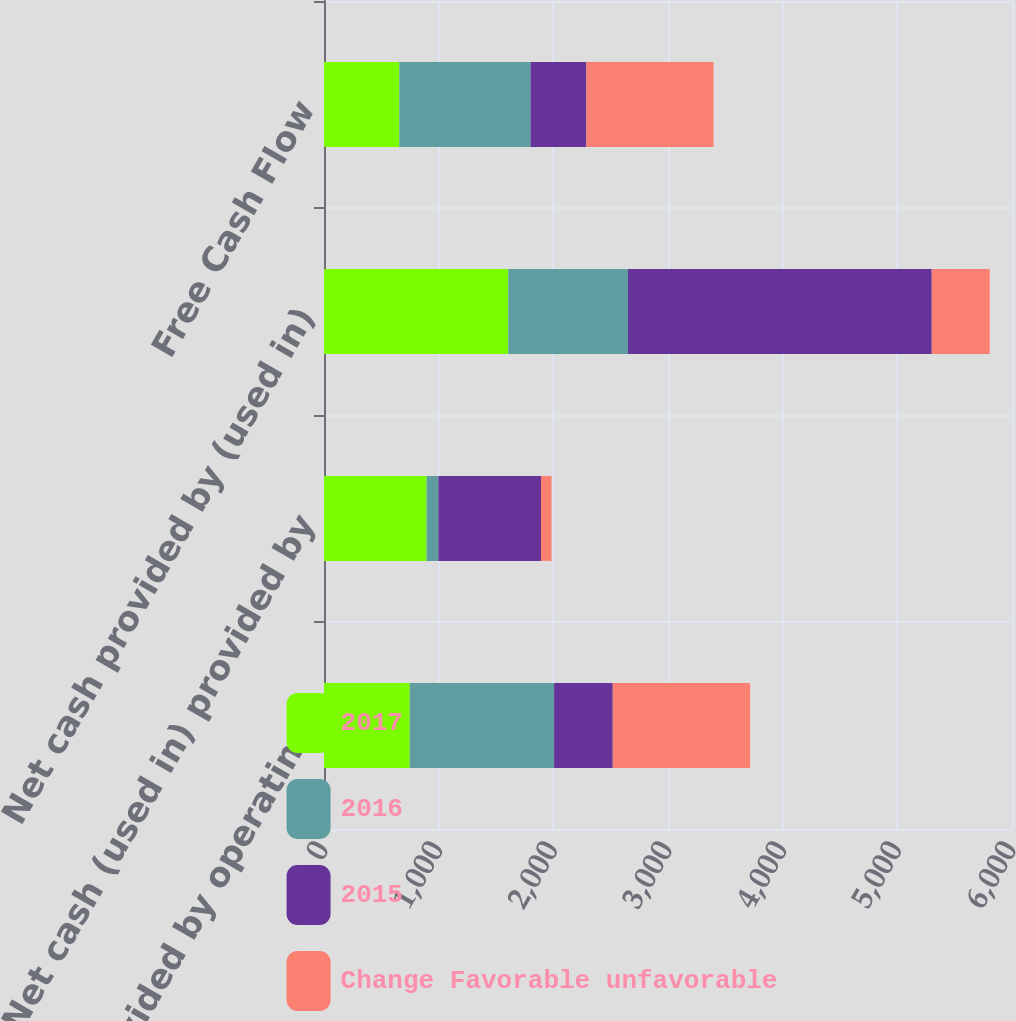Convert chart. <chart><loc_0><loc_0><loc_500><loc_500><stacked_bar_chart><ecel><fcel>Net cash provided by operating<fcel>Net cash (used in) provided by<fcel>Net cash provided by (used in)<fcel>Free Cash Flow<nl><fcel>2017<fcel>747.5<fcel>895.2<fcel>1607.2<fcel>656.9<nl><fcel>2016<fcel>1259.2<fcel>102<fcel>1042.9<fcel>1144<nl><fcel>2015<fcel>511.7<fcel>895.2<fcel>2650.1<fcel>487.1<nl><fcel>Change Favorable unfavorable<fcel>1198.1<fcel>92<fcel>505.5<fcel>1109.1<nl></chart> 